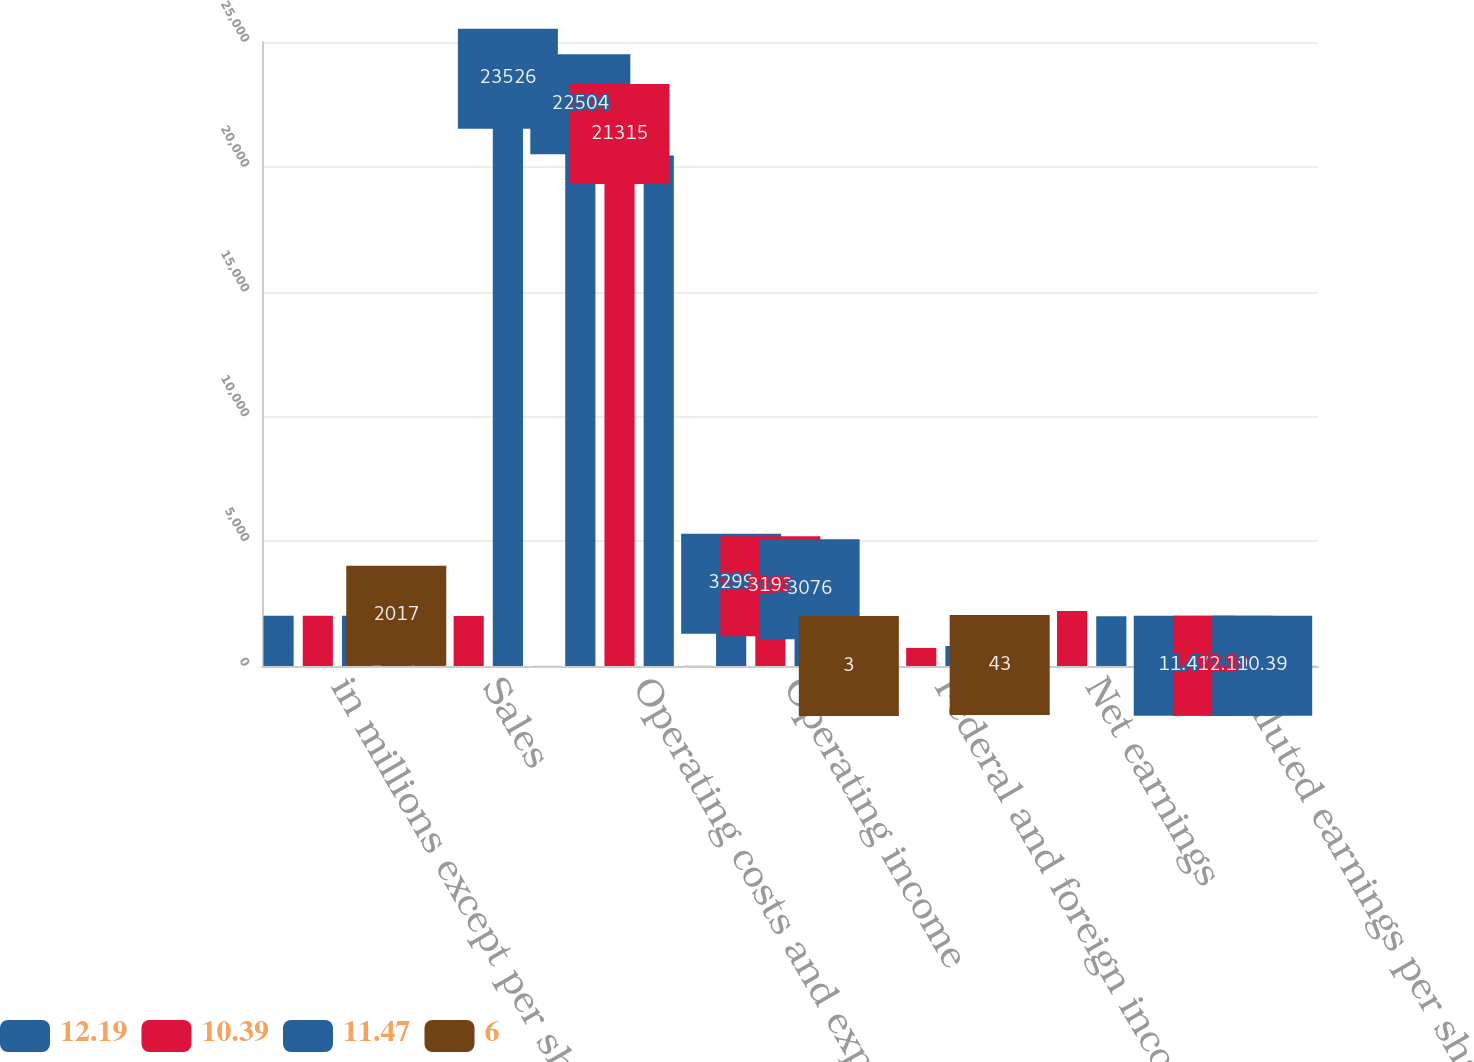Convert chart to OTSL. <chart><loc_0><loc_0><loc_500><loc_500><stacked_bar_chart><ecel><fcel>in millions except per share<fcel>Sales<fcel>Operating costs and expenses<fcel>Operating income<fcel>Federal and foreign income tax<fcel>Net earnings<fcel>Diluted earnings per share<nl><fcel>12.19<fcel>2017<fcel>2002.5<fcel>22504<fcel>3299<fcel>1034<fcel>2015<fcel>11.47<nl><fcel>10.39<fcel>2016<fcel>2002.5<fcel>21315<fcel>3193<fcel>723<fcel>2200<fcel>12.19<nl><fcel>11.47<fcel>2015<fcel>23526<fcel>20450<fcel>3076<fcel>800<fcel>1990<fcel>10.39<nl><fcel>6<fcel>2017<fcel>5<fcel>6<fcel>3<fcel>43<fcel>8<fcel>6<nl></chart> 